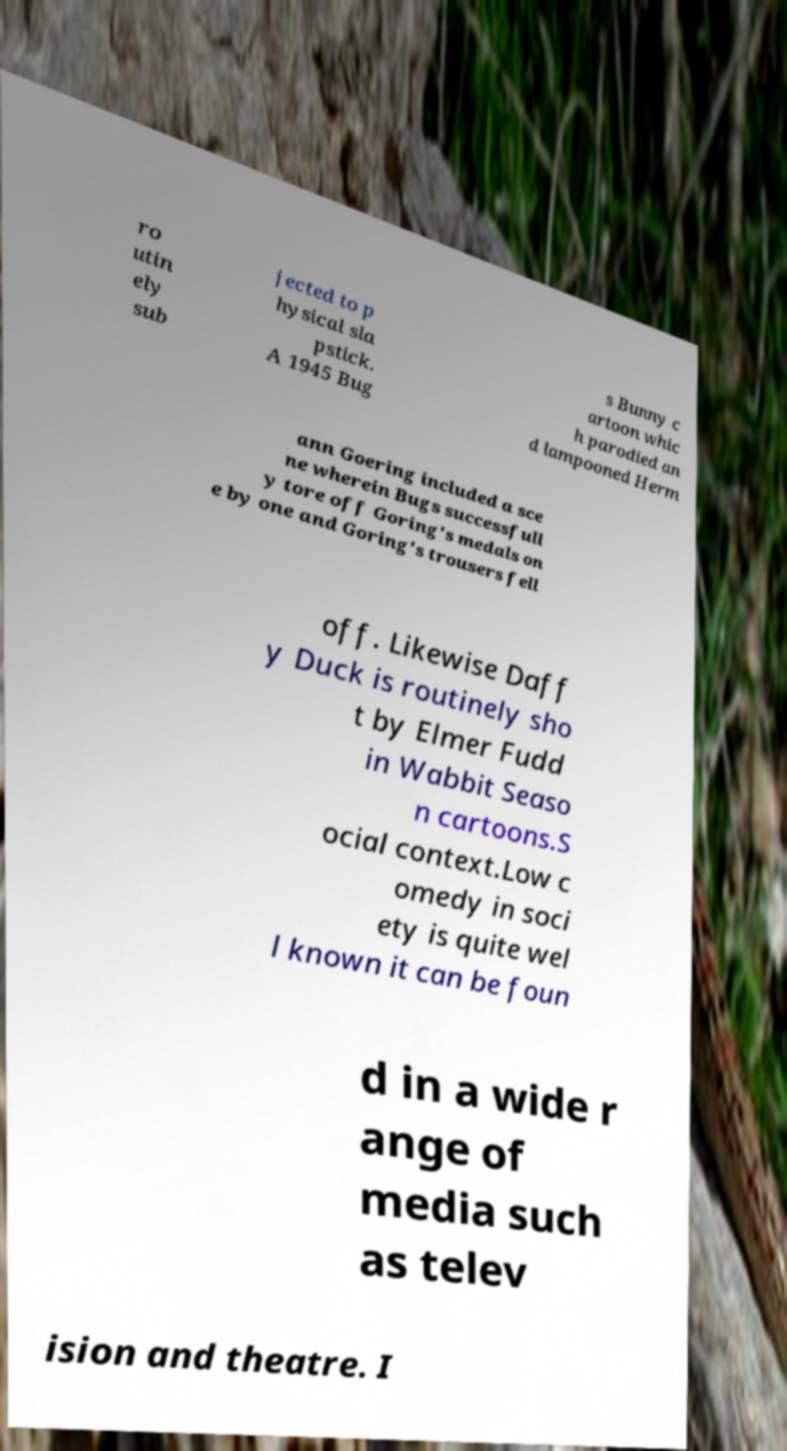Please identify and transcribe the text found in this image. ro utin ely sub jected to p hysical sla pstick. A 1945 Bug s Bunny c artoon whic h parodied an d lampooned Herm ann Goering included a sce ne wherein Bugs successfull y tore off Goring's medals on e by one and Goring's trousers fell off. Likewise Daff y Duck is routinely sho t by Elmer Fudd in Wabbit Seaso n cartoons.S ocial context.Low c omedy in soci ety is quite wel l known it can be foun d in a wide r ange of media such as telev ision and theatre. I 